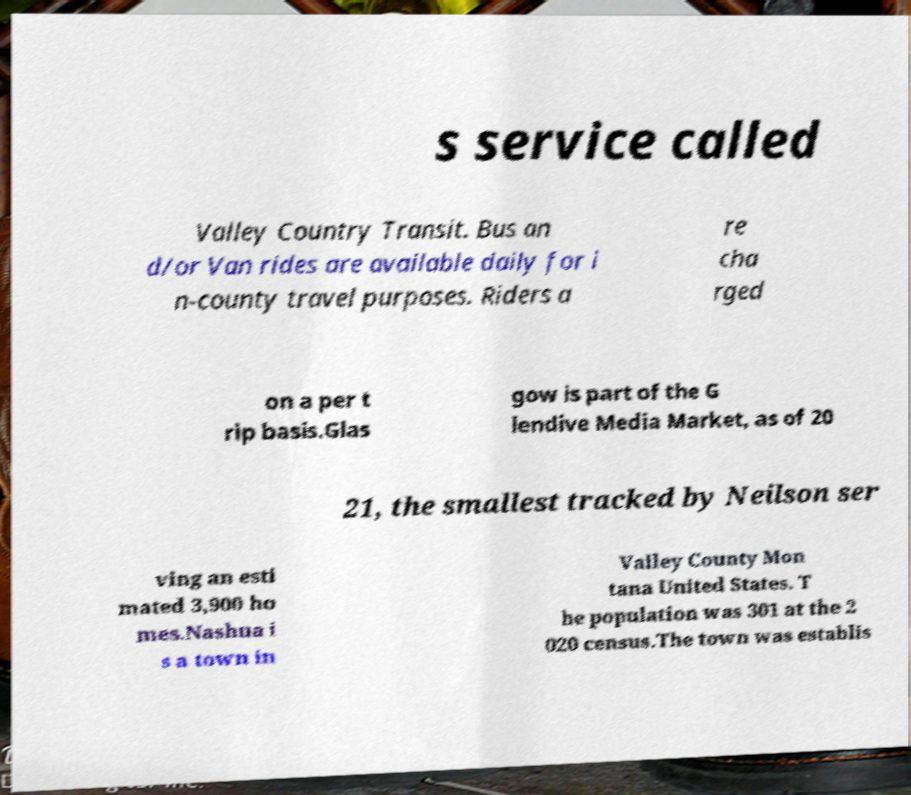Can you read and provide the text displayed in the image?This photo seems to have some interesting text. Can you extract and type it out for me? s service called Valley Country Transit. Bus an d/or Van rides are available daily for i n-county travel purposes. Riders a re cha rged on a per t rip basis.Glas gow is part of the G lendive Media Market, as of 20 21, the smallest tracked by Neilson ser ving an esti mated 3,900 ho mes.Nashua i s a town in Valley County Mon tana United States. T he population was 301 at the 2 020 census.The town was establis 